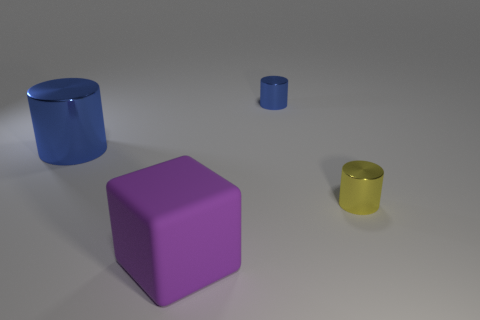What is the size of the other metal thing that is the same color as the large metallic object?
Give a very brief answer. Small. What size is the blue cylinder that is the same material as the small blue object?
Offer a terse response. Large. The small metal object in front of the large object behind the small metallic object in front of the small blue cylinder is what shape?
Make the answer very short. Cylinder. There is a yellow shiny object that is the same shape as the big blue metallic object; what is its size?
Offer a terse response. Small. How big is the object that is behind the big rubber cube and in front of the large metal thing?
Keep it short and to the point. Small. The small thing that is the same color as the large metallic cylinder is what shape?
Provide a short and direct response. Cylinder. What is the color of the large matte object?
Your answer should be compact. Purple. How big is the blue cylinder that is to the right of the matte thing?
Provide a succinct answer. Small. What number of tiny blue cylinders are on the right side of the small object that is to the right of the blue object that is to the right of the purple block?
Ensure brevity in your answer.  0. The big object that is behind the small thing that is in front of the large blue thing is what color?
Offer a terse response. Blue. 